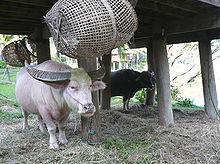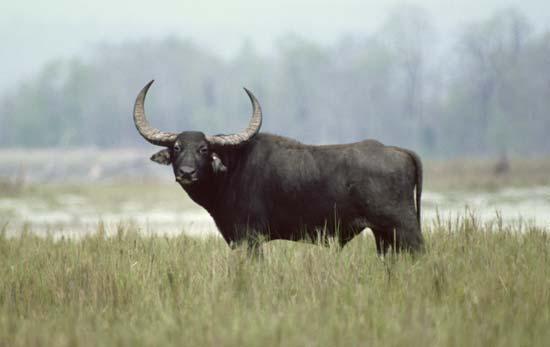The first image is the image on the left, the second image is the image on the right. Assess this claim about the two images: "One animal stands in the grass in the image on the left.". Correct or not? Answer yes or no. No. The first image is the image on the left, the second image is the image on the right. Considering the images on both sides, is "At least 3 cows are standing in a grassy field." valid? Answer yes or no. No. The first image is the image on the left, the second image is the image on the right. Analyze the images presented: Is the assertion "The left image contains more water buffalos than the right image." valid? Answer yes or no. Yes. The first image is the image on the left, the second image is the image on the right. For the images shown, is this caption "There are no more than 3 water buffalo in the pair of images" true? Answer yes or no. Yes. 